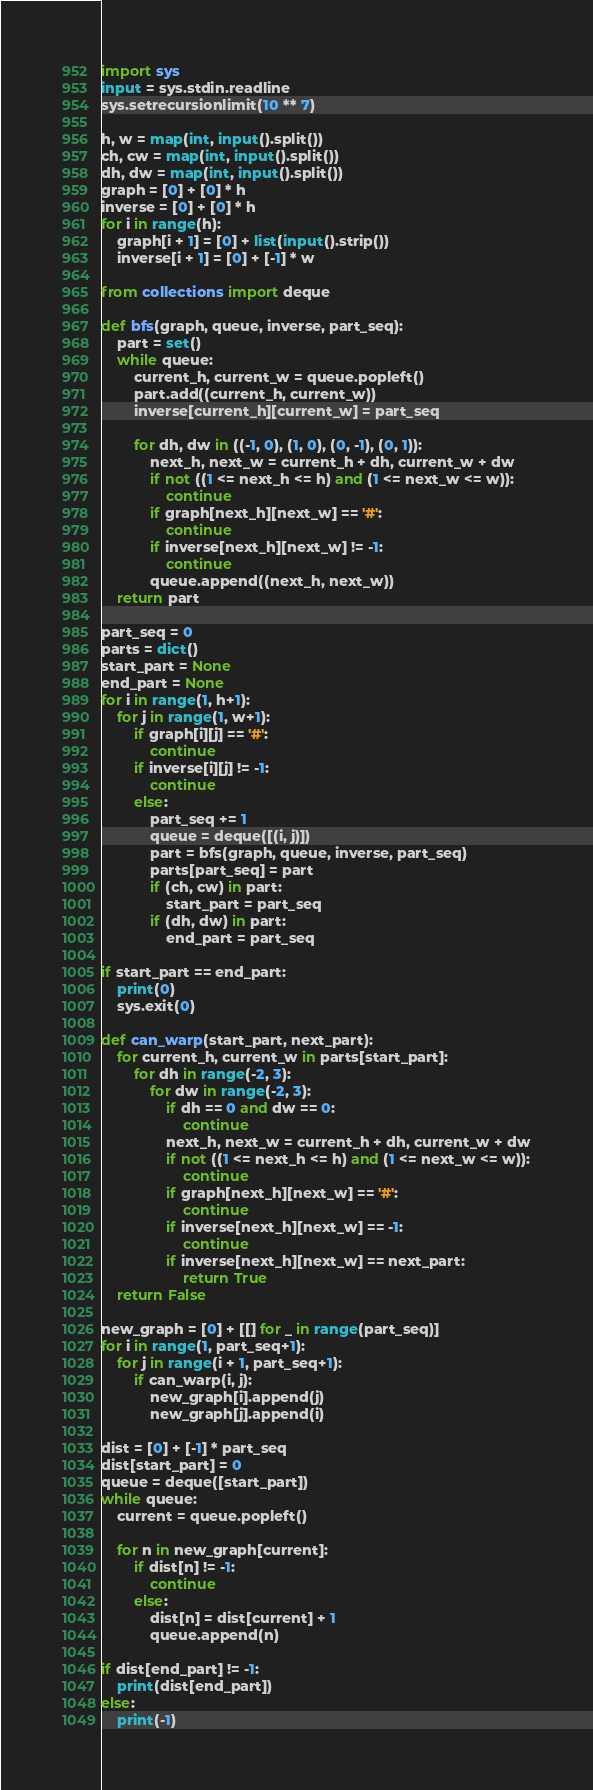Convert code to text. <code><loc_0><loc_0><loc_500><loc_500><_Python_>import sys
input = sys.stdin.readline
sys.setrecursionlimit(10 ** 7)

h, w = map(int, input().split())
ch, cw = map(int, input().split())
dh, dw = map(int, input().split())
graph = [0] + [0] * h
inverse = [0] + [0] * h
for i in range(h):
    graph[i + 1] = [0] + list(input().strip())
    inverse[i + 1] = [0] + [-1] * w

from collections import deque

def bfs(graph, queue, inverse, part_seq):
    part = set()
    while queue:
        current_h, current_w = queue.popleft()
        part.add((current_h, current_w))
        inverse[current_h][current_w] = part_seq

        for dh, dw in ((-1, 0), (1, 0), (0, -1), (0, 1)):
            next_h, next_w = current_h + dh, current_w + dw
            if not ((1 <= next_h <= h) and (1 <= next_w <= w)):
                continue
            if graph[next_h][next_w] == '#':
                continue
            if inverse[next_h][next_w] != -1:
                continue
            queue.append((next_h, next_w))
    return part

part_seq = 0
parts = dict()
start_part = None
end_part = None
for i in range(1, h+1):
    for j in range(1, w+1):
        if graph[i][j] == '#':
            continue
        if inverse[i][j] != -1:
            continue
        else:
            part_seq += 1
            queue = deque([(i, j)])
            part = bfs(graph, queue, inverse, part_seq)
            parts[part_seq] = part
            if (ch, cw) in part:
                start_part = part_seq
            if (dh, dw) in part:
                end_part = part_seq

if start_part == end_part:
    print(0)
    sys.exit(0)

def can_warp(start_part, next_part):
    for current_h, current_w in parts[start_part]:
        for dh in range(-2, 3):
            for dw in range(-2, 3):
                if dh == 0 and dw == 0:
                    continue
                next_h, next_w = current_h + dh, current_w + dw
                if not ((1 <= next_h <= h) and (1 <= next_w <= w)):
                    continue
                if graph[next_h][next_w] == '#':
                    continue
                if inverse[next_h][next_w] == -1:
                    continue
                if inverse[next_h][next_w] == next_part:
                    return True
    return False

new_graph = [0] + [[] for _ in range(part_seq)]
for i in range(1, part_seq+1):
    for j in range(i + 1, part_seq+1):
        if can_warp(i, j):
            new_graph[i].append(j)
            new_graph[j].append(i)

dist = [0] + [-1] * part_seq
dist[start_part] = 0
queue = deque([start_part])
while queue:
    current = queue.popleft()

    for n in new_graph[current]:
        if dist[n] != -1:
            continue
        else:
            dist[n] = dist[current] + 1
            queue.append(n)

if dist[end_part] != -1:
    print(dist[end_part])
else:
    print(-1)</code> 